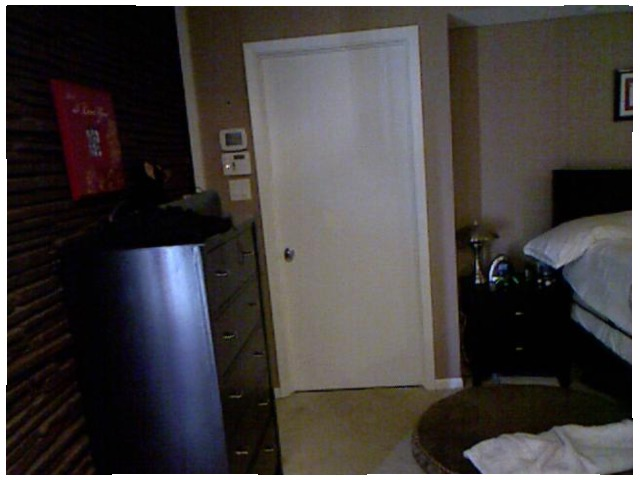<image>
Is there a towel on the carpet? Yes. Looking at the image, I can see the towel is positioned on top of the carpet, with the carpet providing support. 